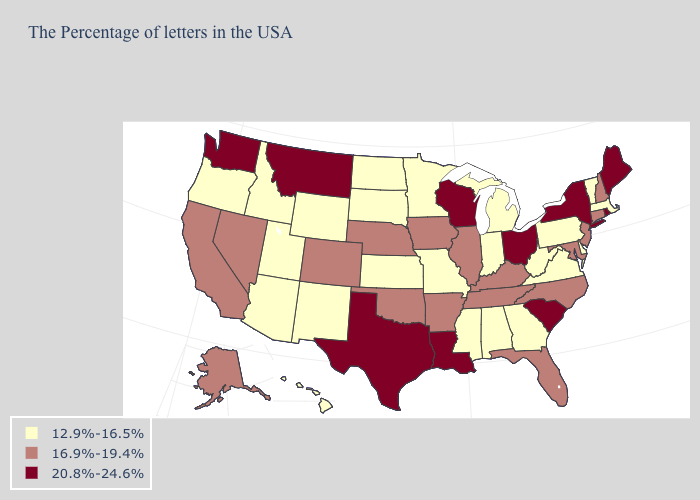Name the states that have a value in the range 20.8%-24.6%?
Keep it brief. Maine, Rhode Island, New York, South Carolina, Ohio, Wisconsin, Louisiana, Texas, Montana, Washington. Name the states that have a value in the range 16.9%-19.4%?
Be succinct. New Hampshire, Connecticut, New Jersey, Maryland, North Carolina, Florida, Kentucky, Tennessee, Illinois, Arkansas, Iowa, Nebraska, Oklahoma, Colorado, Nevada, California, Alaska. What is the value of Wyoming?
Concise answer only. 12.9%-16.5%. Does South Dakota have a lower value than Idaho?
Be succinct. No. What is the value of Wyoming?
Answer briefly. 12.9%-16.5%. How many symbols are there in the legend?
Concise answer only. 3. How many symbols are there in the legend?
Answer briefly. 3. Name the states that have a value in the range 16.9%-19.4%?
Answer briefly. New Hampshire, Connecticut, New Jersey, Maryland, North Carolina, Florida, Kentucky, Tennessee, Illinois, Arkansas, Iowa, Nebraska, Oklahoma, Colorado, Nevada, California, Alaska. What is the highest value in the Northeast ?
Quick response, please. 20.8%-24.6%. Among the states that border Minnesota , does North Dakota have the highest value?
Answer briefly. No. What is the value of Florida?
Quick response, please. 16.9%-19.4%. Does Louisiana have a higher value than Alabama?
Quick response, please. Yes. What is the value of Wisconsin?
Answer briefly. 20.8%-24.6%. Does Tennessee have a higher value than Oklahoma?
Give a very brief answer. No. Does Michigan have a higher value than Oklahoma?
Answer briefly. No. 